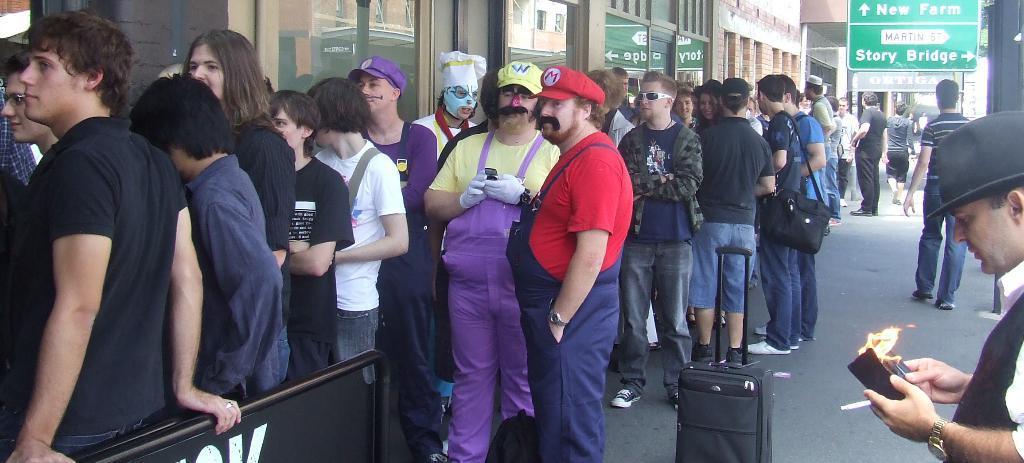In one or two sentences, can you explain what this image depicts? In this image there are a group of people standing in the line, a person is holding a mobile in his hand, a person is holding a barrier gate towardś the left of the image, there is a trolley bag on the road, there is a man holding cigarette and purse towardś the right of the image, there is a board, there are wallś, there are windowś. 